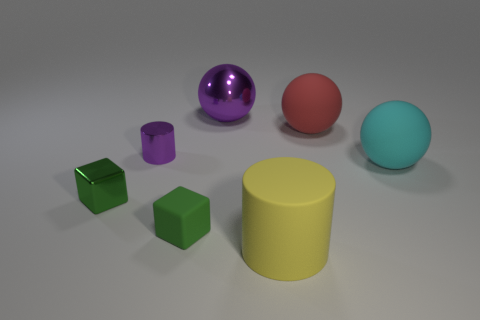Add 1 tiny brown rubber cylinders. How many objects exist? 8 Subtract all cylinders. How many objects are left? 5 Subtract 0 blue blocks. How many objects are left? 7 Subtract all blocks. Subtract all large green shiny balls. How many objects are left? 5 Add 3 big things. How many big things are left? 7 Add 2 small rubber things. How many small rubber things exist? 3 